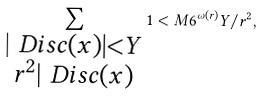<formula> <loc_0><loc_0><loc_500><loc_500>\sum _ { \substack { | \ D i s c ( x ) | < Y \\ r ^ { 2 } | \ D i s c ( x ) } } 1 < M 6 ^ { \omega ( r ) } Y / r ^ { 2 } ,</formula> 